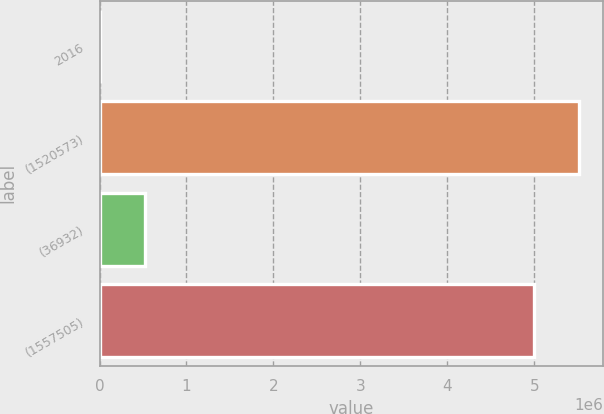Convert chart to OTSL. <chart><loc_0><loc_0><loc_500><loc_500><bar_chart><fcel>2016<fcel>(1520573)<fcel>(36932)<fcel>(1557505)<nl><fcel>2014<fcel>5.51124e+06<fcel>517936<fcel>4.99532e+06<nl></chart> 